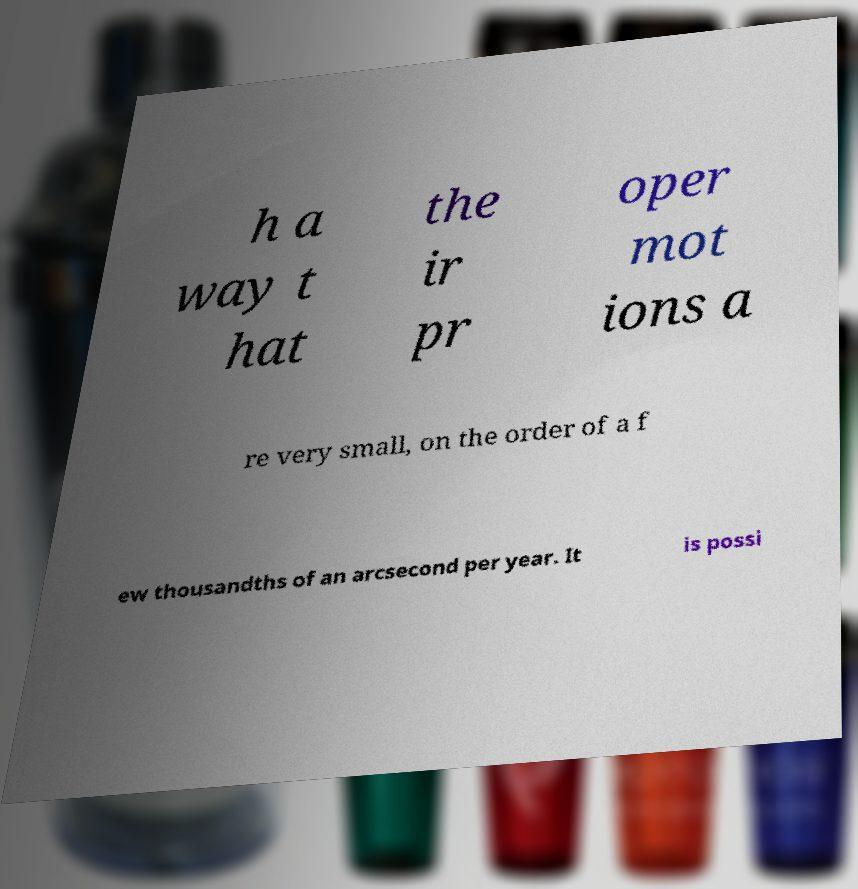Please identify and transcribe the text found in this image. h a way t hat the ir pr oper mot ions a re very small, on the order of a f ew thousandths of an arcsecond per year. It is possi 